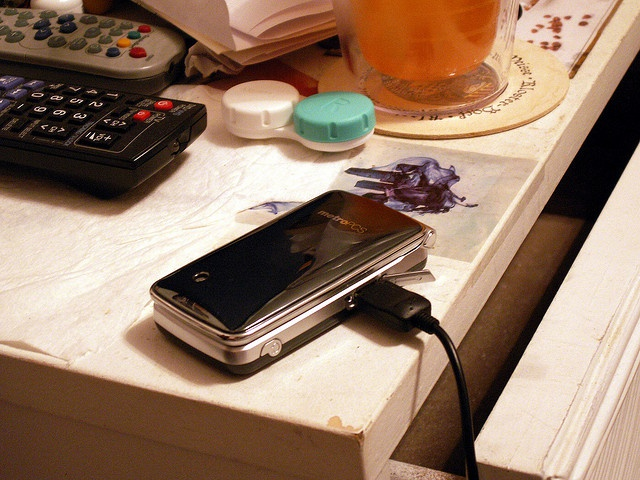Describe the objects in this image and their specific colors. I can see cell phone in black, maroon, and gray tones, cup in black, brown, and red tones, remote in black, maroon, and gray tones, and remote in black, gray, olive, and maroon tones in this image. 